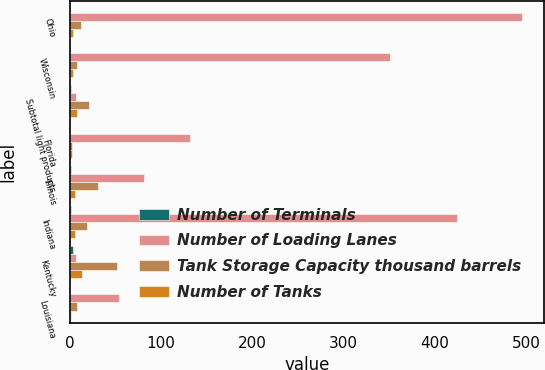Convert chart to OTSL. <chart><loc_0><loc_0><loc_500><loc_500><stacked_bar_chart><ecel><fcel>Ohio<fcel>Wisconsin<fcel>Subtotal light products<fcel>Florida<fcel>Illinois<fcel>Indiana<fcel>Kentucky<fcel>Louisiana<nl><fcel>Number of Terminals<fcel>1<fcel>1<fcel>2<fcel>1<fcel>2<fcel>2<fcel>4<fcel>1<nl><fcel>Number of Loading Lanes<fcel>495<fcel>351<fcel>7<fcel>132<fcel>82<fcel>424<fcel>7<fcel>54<nl><fcel>Tank Storage Capacity thousand barrels<fcel>13<fcel>8<fcel>21<fcel>3<fcel>31<fcel>19<fcel>52<fcel>8<nl><fcel>Number of Tanks<fcel>4<fcel>4<fcel>8<fcel>3<fcel>6<fcel>6<fcel>14<fcel>2<nl></chart> 